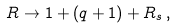<formula> <loc_0><loc_0><loc_500><loc_500>R \rightarrow 1 + ( q + 1 ) + R _ { s } \, ,</formula> 